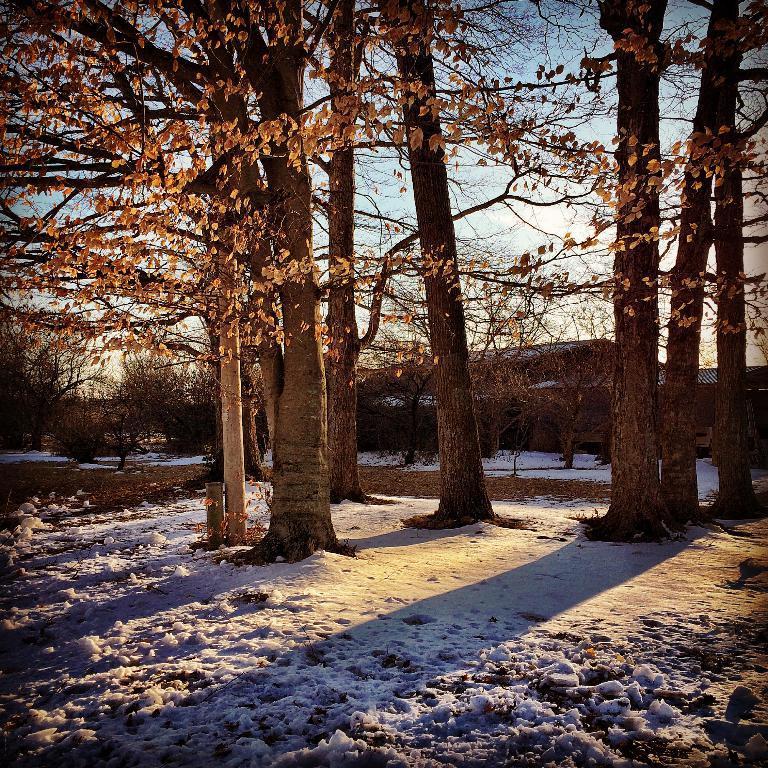Describe this image in one or two sentences. In this image at the bottom there is some snow and in the background there are some trees and houses, on the top of the image there is sky. 